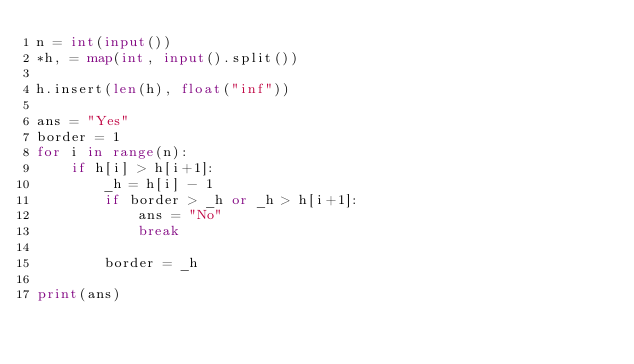Convert code to text. <code><loc_0><loc_0><loc_500><loc_500><_Python_>n = int(input())
*h, = map(int, input().split())

h.insert(len(h), float("inf"))

ans = "Yes"
border = 1
for i in range(n):
    if h[i] > h[i+1]:
        _h = h[i] - 1
        if border > _h or _h > h[i+1]:
            ans = "No"
            break

        border = _h

print(ans)
</code> 